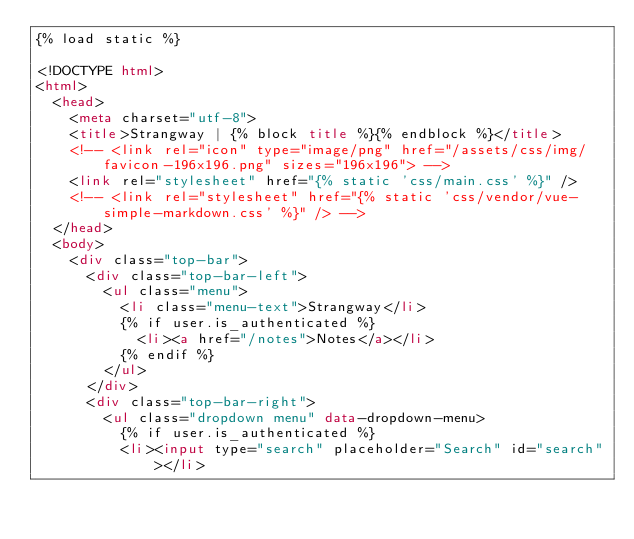<code> <loc_0><loc_0><loc_500><loc_500><_HTML_>{% load static %}

<!DOCTYPE html>
<html>
  <head>
    <meta charset="utf-8">
    <title>Strangway | {% block title %}{% endblock %}</title>
    <!-- <link rel="icon" type="image/png" href="/assets/css/img/favicon-196x196.png" sizes="196x196"> -->
    <link rel="stylesheet" href="{% static 'css/main.css' %}" />
    <!-- <link rel="stylesheet" href="{% static 'css/vendor/vue-simple-markdown.css' %}" /> -->
  </head>
  <body>
    <div class="top-bar">
      <div class="top-bar-left">
        <ul class="menu">
          <li class="menu-text">Strangway</li>
          {% if user.is_authenticated %}
            <li><a href="/notes">Notes</a></li>
          {% endif %}
        </ul>
      </div>
      <div class="top-bar-right">
        <ul class="dropdown menu" data-dropdown-menu>
          {% if user.is_authenticated %}
          <li><input type="search" placeholder="Search" id="search"></li></code> 